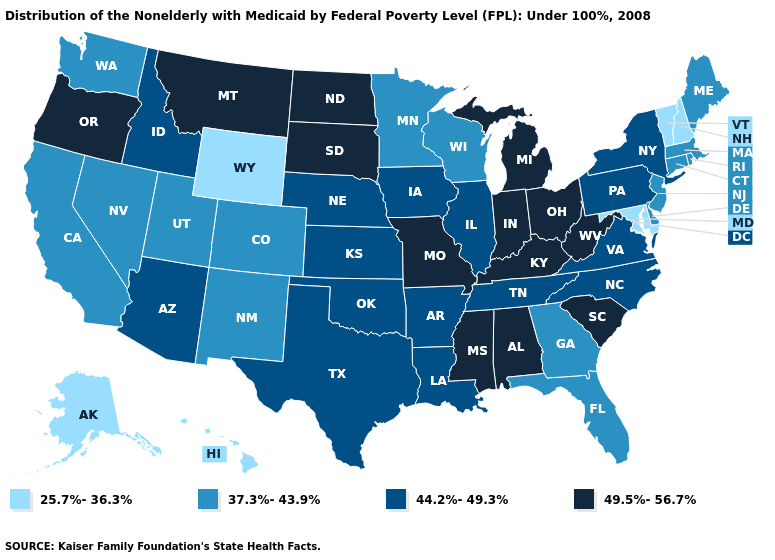What is the value of Kansas?
Give a very brief answer. 44.2%-49.3%. What is the highest value in the USA?
Concise answer only. 49.5%-56.7%. Name the states that have a value in the range 44.2%-49.3%?
Give a very brief answer. Arizona, Arkansas, Idaho, Illinois, Iowa, Kansas, Louisiana, Nebraska, New York, North Carolina, Oklahoma, Pennsylvania, Tennessee, Texas, Virginia. Among the states that border Oklahoma , which have the highest value?
Short answer required. Missouri. What is the value of Maryland?
Answer briefly. 25.7%-36.3%. Which states have the lowest value in the South?
Quick response, please. Maryland. Does Hawaii have the lowest value in the West?
Give a very brief answer. Yes. Does the first symbol in the legend represent the smallest category?
Answer briefly. Yes. Does the first symbol in the legend represent the smallest category?
Be succinct. Yes. What is the value of California?
Concise answer only. 37.3%-43.9%. Name the states that have a value in the range 25.7%-36.3%?
Give a very brief answer. Alaska, Hawaii, Maryland, New Hampshire, Vermont, Wyoming. Does the first symbol in the legend represent the smallest category?
Quick response, please. Yes. Does Montana have the highest value in the West?
Quick response, please. Yes. Name the states that have a value in the range 25.7%-36.3%?
Concise answer only. Alaska, Hawaii, Maryland, New Hampshire, Vermont, Wyoming. 